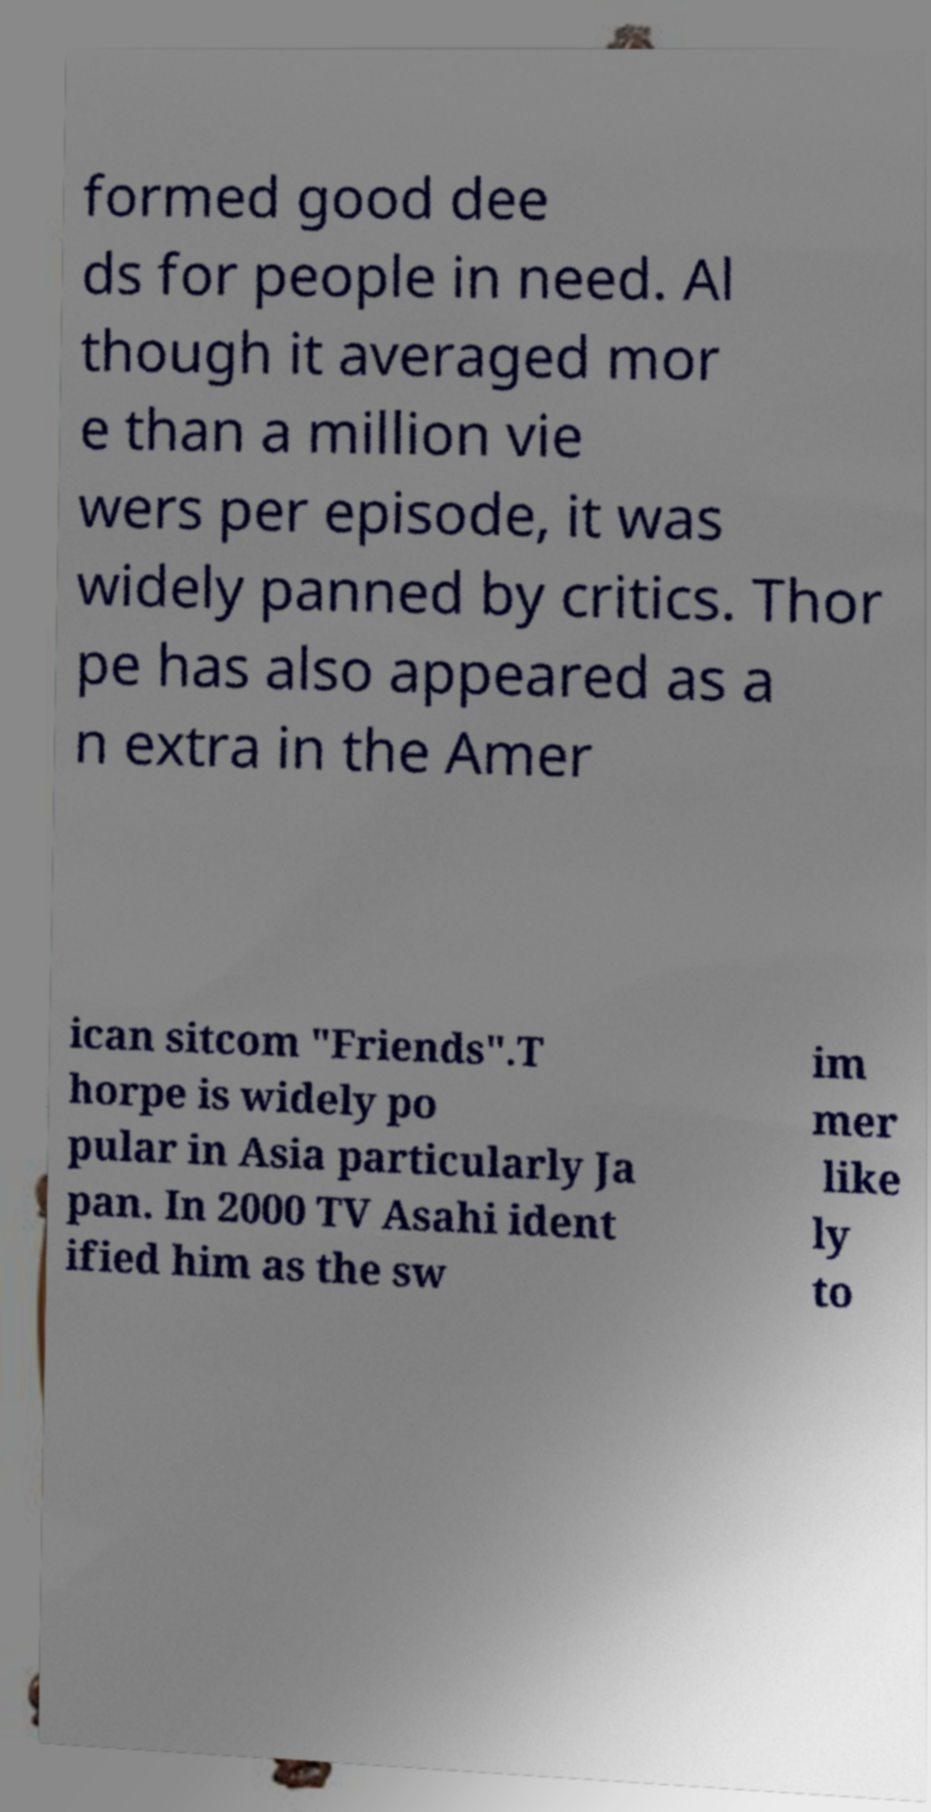Please read and relay the text visible in this image. What does it say? formed good dee ds for people in need. Al though it averaged mor e than a million vie wers per episode, it was widely panned by critics. Thor pe has also appeared as a n extra in the Amer ican sitcom "Friends".T horpe is widely po pular in Asia particularly Ja pan. In 2000 TV Asahi ident ified him as the sw im mer like ly to 